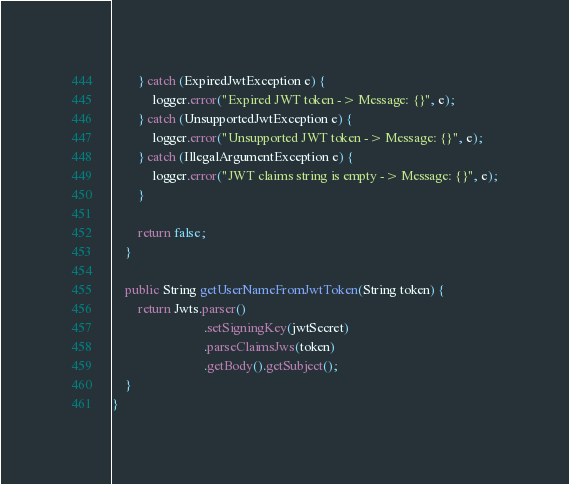Convert code to text. <code><loc_0><loc_0><loc_500><loc_500><_Java_>        } catch (ExpiredJwtException e) {
            logger.error("Expired JWT token -> Message: {}", e);
        } catch (UnsupportedJwtException e) {
            logger.error("Unsupported JWT token -> Message: {}", e);
        } catch (IllegalArgumentException e) {
            logger.error("JWT claims string is empty -> Message: {}", e);
        }
        
        return false;
    }
    
    public String getUserNameFromJwtToken(String token) {
        return Jwts.parser()
			                .setSigningKey(jwtSecret)
			                .parseClaimsJws(token)
			                .getBody().getSubject();
    }
}</code> 